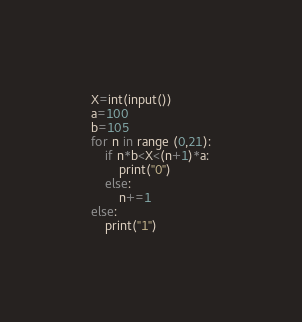Convert code to text. <code><loc_0><loc_0><loc_500><loc_500><_Python_>X=int(input())
a=100
b=105
for n in range (0,21):
    if n*b<X<(n+1)*a:
        print("0")
    else:
        n+=1
else:
    print("1")</code> 